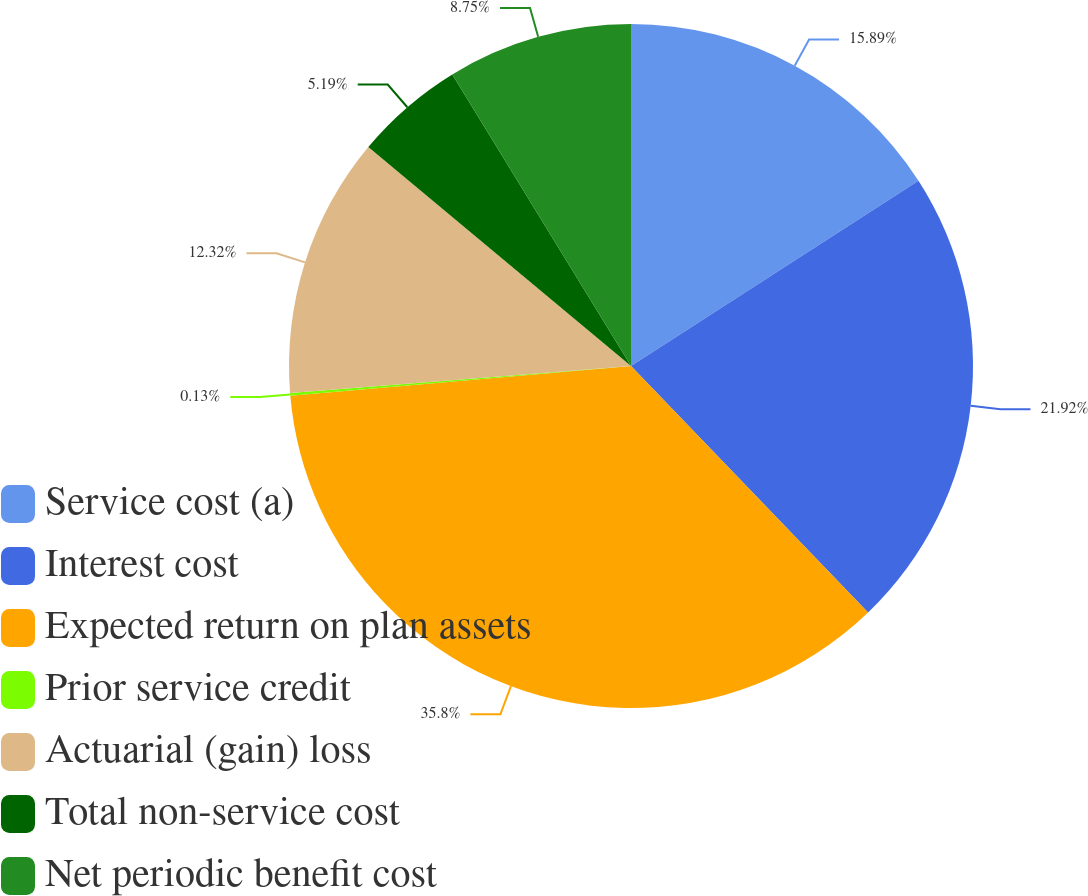Convert chart. <chart><loc_0><loc_0><loc_500><loc_500><pie_chart><fcel>Service cost (a)<fcel>Interest cost<fcel>Expected return on plan assets<fcel>Prior service credit<fcel>Actuarial (gain) loss<fcel>Total non-service cost<fcel>Net periodic benefit cost<nl><fcel>15.89%<fcel>21.92%<fcel>35.8%<fcel>0.13%<fcel>12.32%<fcel>5.19%<fcel>8.75%<nl></chart> 